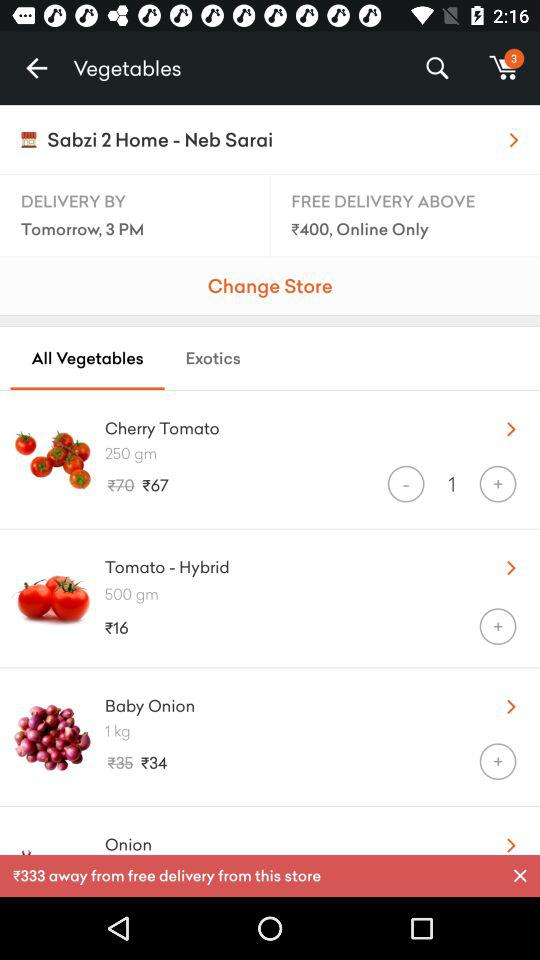What is the purchase amount required for free delivery? The purchase amount required for free delivery is above ₹400. 